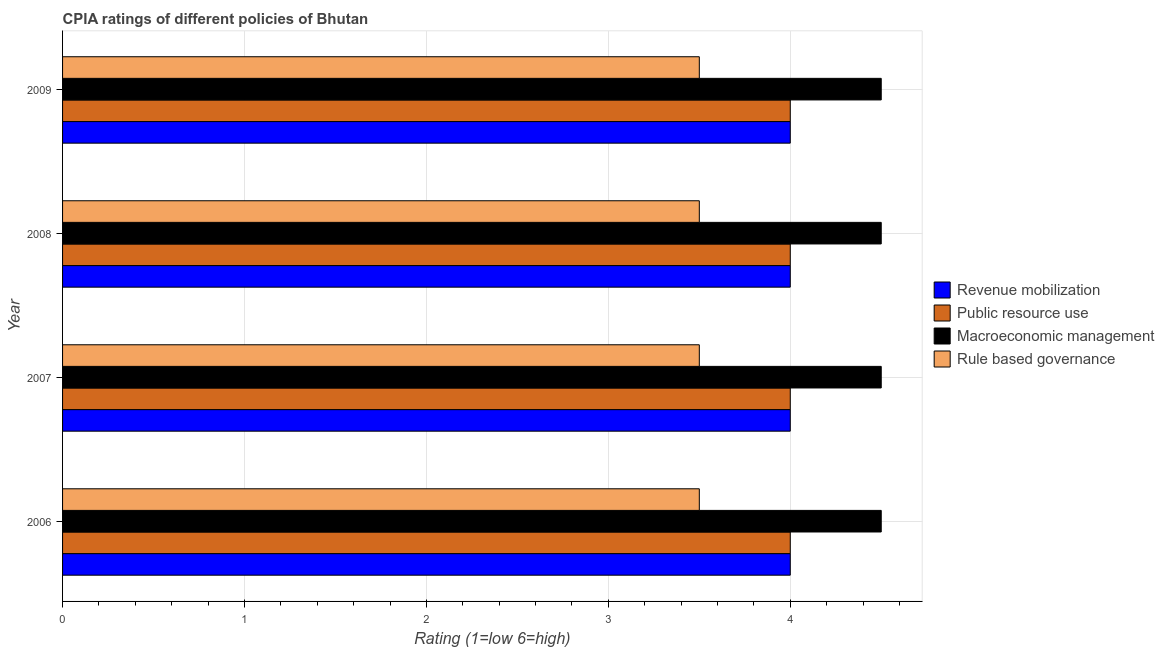How many different coloured bars are there?
Offer a very short reply. 4. Are the number of bars on each tick of the Y-axis equal?
Keep it short and to the point. Yes. How many bars are there on the 2nd tick from the top?
Your response must be concise. 4. How many bars are there on the 1st tick from the bottom?
Offer a very short reply. 4. What is the label of the 1st group of bars from the top?
Keep it short and to the point. 2009. In how many cases, is the number of bars for a given year not equal to the number of legend labels?
Your answer should be very brief. 0. Across all years, what is the minimum cpia rating of revenue mobilization?
Provide a short and direct response. 4. In which year was the cpia rating of public resource use maximum?
Offer a very short reply. 2006. In which year was the cpia rating of revenue mobilization minimum?
Ensure brevity in your answer.  2006. What is the total cpia rating of revenue mobilization in the graph?
Offer a terse response. 16. In the year 2006, what is the difference between the cpia rating of rule based governance and cpia rating of public resource use?
Keep it short and to the point. -0.5. What is the ratio of the cpia rating of revenue mobilization in 2006 to that in 2007?
Provide a succinct answer. 1. Is the difference between the cpia rating of macroeconomic management in 2006 and 2008 greater than the difference between the cpia rating of public resource use in 2006 and 2008?
Give a very brief answer. No. What is the difference between the highest and the lowest cpia rating of rule based governance?
Your answer should be compact. 0. In how many years, is the cpia rating of revenue mobilization greater than the average cpia rating of revenue mobilization taken over all years?
Your answer should be compact. 0. What does the 1st bar from the top in 2006 represents?
Offer a very short reply. Rule based governance. What does the 1st bar from the bottom in 2007 represents?
Give a very brief answer. Revenue mobilization. Is it the case that in every year, the sum of the cpia rating of revenue mobilization and cpia rating of public resource use is greater than the cpia rating of macroeconomic management?
Provide a short and direct response. Yes. How many bars are there?
Offer a very short reply. 16. Are all the bars in the graph horizontal?
Give a very brief answer. Yes. What is the difference between two consecutive major ticks on the X-axis?
Your answer should be compact. 1. Does the graph contain grids?
Ensure brevity in your answer.  Yes. Where does the legend appear in the graph?
Provide a short and direct response. Center right. How many legend labels are there?
Provide a succinct answer. 4. How are the legend labels stacked?
Your response must be concise. Vertical. What is the title of the graph?
Your response must be concise. CPIA ratings of different policies of Bhutan. Does "Denmark" appear as one of the legend labels in the graph?
Your answer should be very brief. No. What is the label or title of the X-axis?
Make the answer very short. Rating (1=low 6=high). What is the label or title of the Y-axis?
Provide a succinct answer. Year. What is the Rating (1=low 6=high) in Revenue mobilization in 2006?
Provide a short and direct response. 4. What is the Rating (1=low 6=high) of Macroeconomic management in 2006?
Provide a short and direct response. 4.5. What is the Rating (1=low 6=high) of Rule based governance in 2006?
Give a very brief answer. 3.5. What is the Rating (1=low 6=high) of Public resource use in 2007?
Make the answer very short. 4. What is the Rating (1=low 6=high) in Revenue mobilization in 2008?
Ensure brevity in your answer.  4. What is the Rating (1=low 6=high) in Macroeconomic management in 2008?
Your answer should be compact. 4.5. What is the Rating (1=low 6=high) of Rule based governance in 2008?
Your response must be concise. 3.5. What is the Rating (1=low 6=high) of Revenue mobilization in 2009?
Offer a very short reply. 4. Across all years, what is the maximum Rating (1=low 6=high) in Macroeconomic management?
Your answer should be compact. 4.5. What is the total Rating (1=low 6=high) of Revenue mobilization in the graph?
Provide a succinct answer. 16. What is the total Rating (1=low 6=high) in Public resource use in the graph?
Make the answer very short. 16. What is the total Rating (1=low 6=high) in Rule based governance in the graph?
Provide a short and direct response. 14. What is the difference between the Rating (1=low 6=high) in Public resource use in 2006 and that in 2007?
Offer a very short reply. 0. What is the difference between the Rating (1=low 6=high) in Macroeconomic management in 2006 and that in 2007?
Your answer should be compact. 0. What is the difference between the Rating (1=low 6=high) of Rule based governance in 2006 and that in 2007?
Your answer should be very brief. 0. What is the difference between the Rating (1=low 6=high) of Revenue mobilization in 2006 and that in 2008?
Provide a short and direct response. 0. What is the difference between the Rating (1=low 6=high) of Rule based governance in 2006 and that in 2008?
Ensure brevity in your answer.  0. What is the difference between the Rating (1=low 6=high) of Public resource use in 2006 and that in 2009?
Keep it short and to the point. 0. What is the difference between the Rating (1=low 6=high) in Rule based governance in 2006 and that in 2009?
Make the answer very short. 0. What is the difference between the Rating (1=low 6=high) in Revenue mobilization in 2007 and that in 2008?
Your response must be concise. 0. What is the difference between the Rating (1=low 6=high) in Revenue mobilization in 2007 and that in 2009?
Your answer should be very brief. 0. What is the difference between the Rating (1=low 6=high) in Public resource use in 2007 and that in 2009?
Provide a short and direct response. 0. What is the difference between the Rating (1=low 6=high) in Macroeconomic management in 2007 and that in 2009?
Offer a very short reply. 0. What is the difference between the Rating (1=low 6=high) in Revenue mobilization in 2008 and that in 2009?
Give a very brief answer. 0. What is the difference between the Rating (1=low 6=high) in Macroeconomic management in 2008 and that in 2009?
Keep it short and to the point. 0. What is the difference between the Rating (1=low 6=high) in Rule based governance in 2008 and that in 2009?
Provide a succinct answer. 0. What is the difference between the Rating (1=low 6=high) of Revenue mobilization in 2006 and the Rating (1=low 6=high) of Public resource use in 2007?
Provide a succinct answer. 0. What is the difference between the Rating (1=low 6=high) in Revenue mobilization in 2006 and the Rating (1=low 6=high) in Rule based governance in 2007?
Your answer should be compact. 0.5. What is the difference between the Rating (1=low 6=high) in Public resource use in 2006 and the Rating (1=low 6=high) in Macroeconomic management in 2007?
Provide a succinct answer. -0.5. What is the difference between the Rating (1=low 6=high) of Public resource use in 2006 and the Rating (1=low 6=high) of Rule based governance in 2007?
Ensure brevity in your answer.  0.5. What is the difference between the Rating (1=low 6=high) of Macroeconomic management in 2006 and the Rating (1=low 6=high) of Rule based governance in 2007?
Provide a short and direct response. 1. What is the difference between the Rating (1=low 6=high) in Revenue mobilization in 2006 and the Rating (1=low 6=high) in Macroeconomic management in 2008?
Your response must be concise. -0.5. What is the difference between the Rating (1=low 6=high) of Revenue mobilization in 2006 and the Rating (1=low 6=high) of Rule based governance in 2008?
Provide a short and direct response. 0.5. What is the difference between the Rating (1=low 6=high) of Public resource use in 2006 and the Rating (1=low 6=high) of Rule based governance in 2008?
Give a very brief answer. 0.5. What is the difference between the Rating (1=low 6=high) in Revenue mobilization in 2006 and the Rating (1=low 6=high) in Macroeconomic management in 2009?
Keep it short and to the point. -0.5. What is the difference between the Rating (1=low 6=high) in Revenue mobilization in 2006 and the Rating (1=low 6=high) in Rule based governance in 2009?
Keep it short and to the point. 0.5. What is the difference between the Rating (1=low 6=high) in Public resource use in 2007 and the Rating (1=low 6=high) in Rule based governance in 2008?
Ensure brevity in your answer.  0.5. What is the difference between the Rating (1=low 6=high) of Public resource use in 2007 and the Rating (1=low 6=high) of Macroeconomic management in 2009?
Provide a short and direct response. -0.5. What is the difference between the Rating (1=low 6=high) in Macroeconomic management in 2007 and the Rating (1=low 6=high) in Rule based governance in 2009?
Provide a succinct answer. 1. What is the difference between the Rating (1=low 6=high) in Revenue mobilization in 2008 and the Rating (1=low 6=high) in Macroeconomic management in 2009?
Ensure brevity in your answer.  -0.5. What is the difference between the Rating (1=low 6=high) in Macroeconomic management in 2008 and the Rating (1=low 6=high) in Rule based governance in 2009?
Make the answer very short. 1. What is the average Rating (1=low 6=high) in Revenue mobilization per year?
Your answer should be very brief. 4. What is the average Rating (1=low 6=high) of Macroeconomic management per year?
Give a very brief answer. 4.5. In the year 2006, what is the difference between the Rating (1=low 6=high) in Revenue mobilization and Rating (1=low 6=high) in Public resource use?
Your answer should be very brief. 0. In the year 2006, what is the difference between the Rating (1=low 6=high) of Revenue mobilization and Rating (1=low 6=high) of Macroeconomic management?
Offer a terse response. -0.5. In the year 2006, what is the difference between the Rating (1=low 6=high) of Revenue mobilization and Rating (1=low 6=high) of Rule based governance?
Your answer should be very brief. 0.5. In the year 2006, what is the difference between the Rating (1=low 6=high) in Public resource use and Rating (1=low 6=high) in Rule based governance?
Provide a succinct answer. 0.5. In the year 2007, what is the difference between the Rating (1=low 6=high) in Revenue mobilization and Rating (1=low 6=high) in Rule based governance?
Your answer should be very brief. 0.5. In the year 2007, what is the difference between the Rating (1=low 6=high) of Public resource use and Rating (1=low 6=high) of Rule based governance?
Offer a terse response. 0.5. In the year 2007, what is the difference between the Rating (1=low 6=high) in Macroeconomic management and Rating (1=low 6=high) in Rule based governance?
Make the answer very short. 1. In the year 2008, what is the difference between the Rating (1=low 6=high) in Revenue mobilization and Rating (1=low 6=high) in Public resource use?
Provide a short and direct response. 0. In the year 2008, what is the difference between the Rating (1=low 6=high) in Revenue mobilization and Rating (1=low 6=high) in Macroeconomic management?
Your answer should be compact. -0.5. In the year 2008, what is the difference between the Rating (1=low 6=high) in Revenue mobilization and Rating (1=low 6=high) in Rule based governance?
Provide a short and direct response. 0.5. In the year 2008, what is the difference between the Rating (1=low 6=high) in Public resource use and Rating (1=low 6=high) in Macroeconomic management?
Give a very brief answer. -0.5. In the year 2008, what is the difference between the Rating (1=low 6=high) of Public resource use and Rating (1=low 6=high) of Rule based governance?
Ensure brevity in your answer.  0.5. In the year 2009, what is the difference between the Rating (1=low 6=high) in Revenue mobilization and Rating (1=low 6=high) in Public resource use?
Offer a very short reply. 0. In the year 2009, what is the difference between the Rating (1=low 6=high) of Revenue mobilization and Rating (1=low 6=high) of Macroeconomic management?
Provide a short and direct response. -0.5. In the year 2009, what is the difference between the Rating (1=low 6=high) in Public resource use and Rating (1=low 6=high) in Macroeconomic management?
Ensure brevity in your answer.  -0.5. In the year 2009, what is the difference between the Rating (1=low 6=high) of Macroeconomic management and Rating (1=low 6=high) of Rule based governance?
Ensure brevity in your answer.  1. What is the ratio of the Rating (1=low 6=high) of Public resource use in 2006 to that in 2007?
Offer a terse response. 1. What is the ratio of the Rating (1=low 6=high) in Macroeconomic management in 2006 to that in 2008?
Offer a terse response. 1. What is the ratio of the Rating (1=low 6=high) of Rule based governance in 2006 to that in 2008?
Your answer should be compact. 1. What is the ratio of the Rating (1=low 6=high) in Revenue mobilization in 2006 to that in 2009?
Make the answer very short. 1. What is the ratio of the Rating (1=low 6=high) of Public resource use in 2006 to that in 2009?
Your answer should be very brief. 1. What is the ratio of the Rating (1=low 6=high) of Revenue mobilization in 2007 to that in 2008?
Provide a short and direct response. 1. What is the ratio of the Rating (1=low 6=high) in Public resource use in 2008 to that in 2009?
Your answer should be compact. 1. What is the ratio of the Rating (1=low 6=high) in Rule based governance in 2008 to that in 2009?
Make the answer very short. 1. What is the difference between the highest and the second highest Rating (1=low 6=high) in Revenue mobilization?
Give a very brief answer. 0. What is the difference between the highest and the lowest Rating (1=low 6=high) of Rule based governance?
Offer a very short reply. 0. 